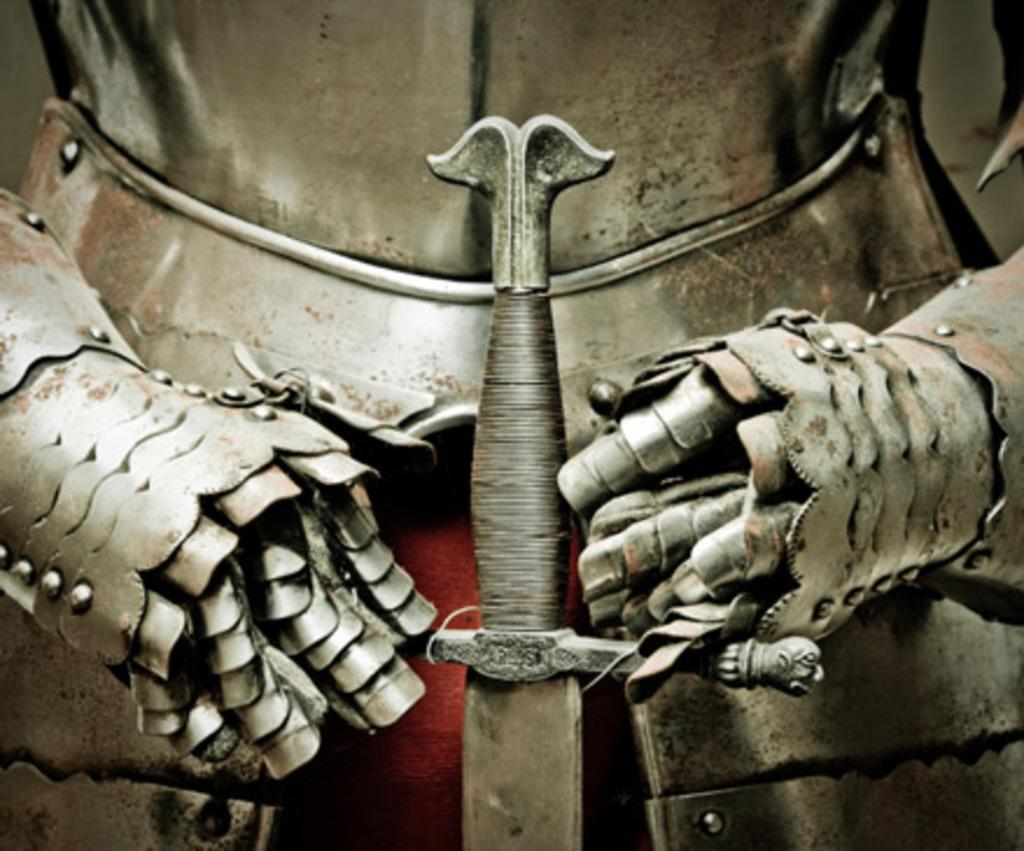What type of protective gear is present in the image? There is an armor in the image. What weapon is visible in the image? There is a sword in the image. What type of treatment is being administered to the armor in the image? There is no treatment being administered to the armor in the image; it is a static object. What is the temperature of the ice in the image? There is no ice present in the image. 